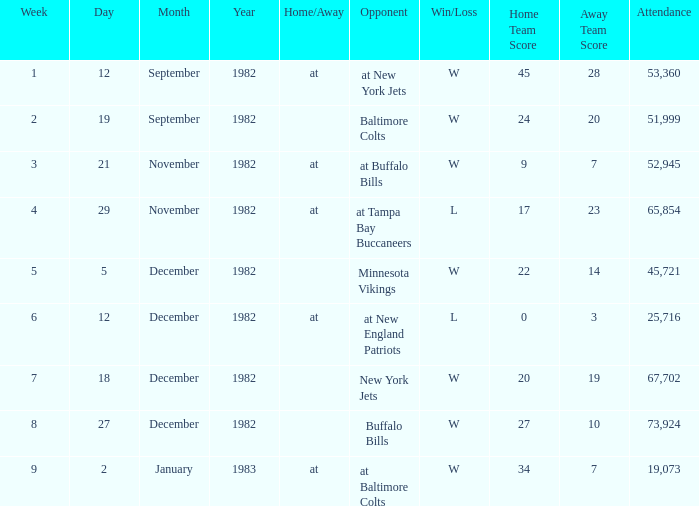What week was the game on September 12, 1982 with an attendance greater than 51,999? 1.0. 